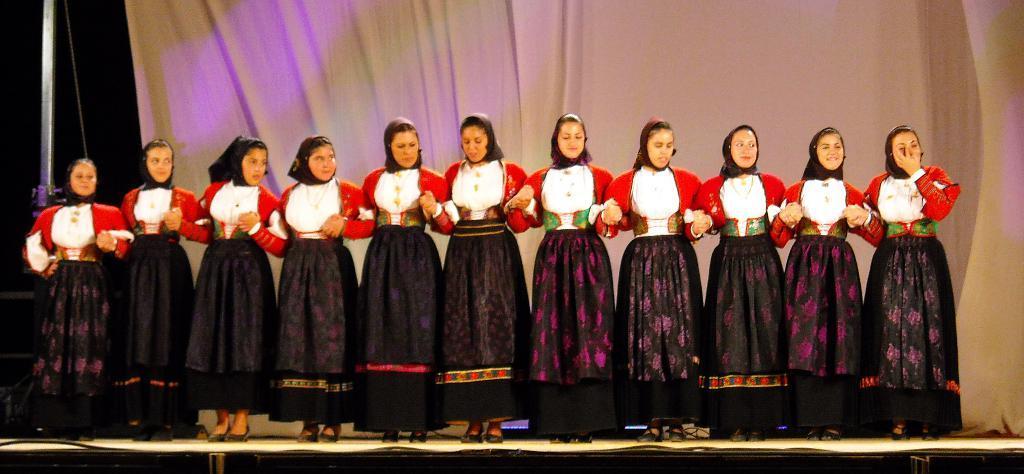Please provide a concise description of this image. In the image few people are standing and smiling. Behind them there is a curtain and pole. 